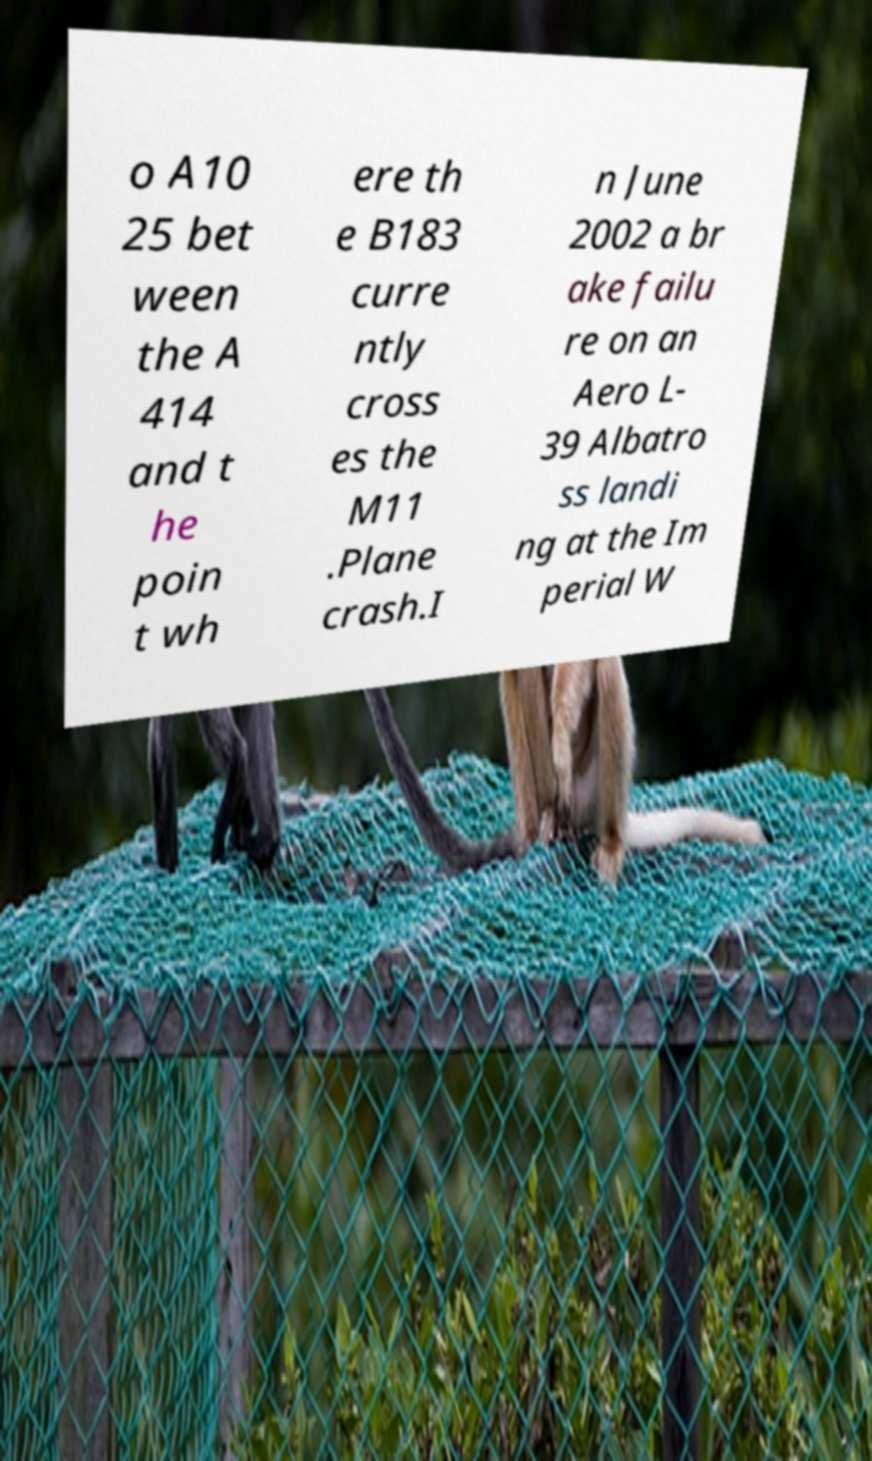I need the written content from this picture converted into text. Can you do that? o A10 25 bet ween the A 414 and t he poin t wh ere th e B183 curre ntly cross es the M11 .Plane crash.I n June 2002 a br ake failu re on an Aero L- 39 Albatro ss landi ng at the Im perial W 